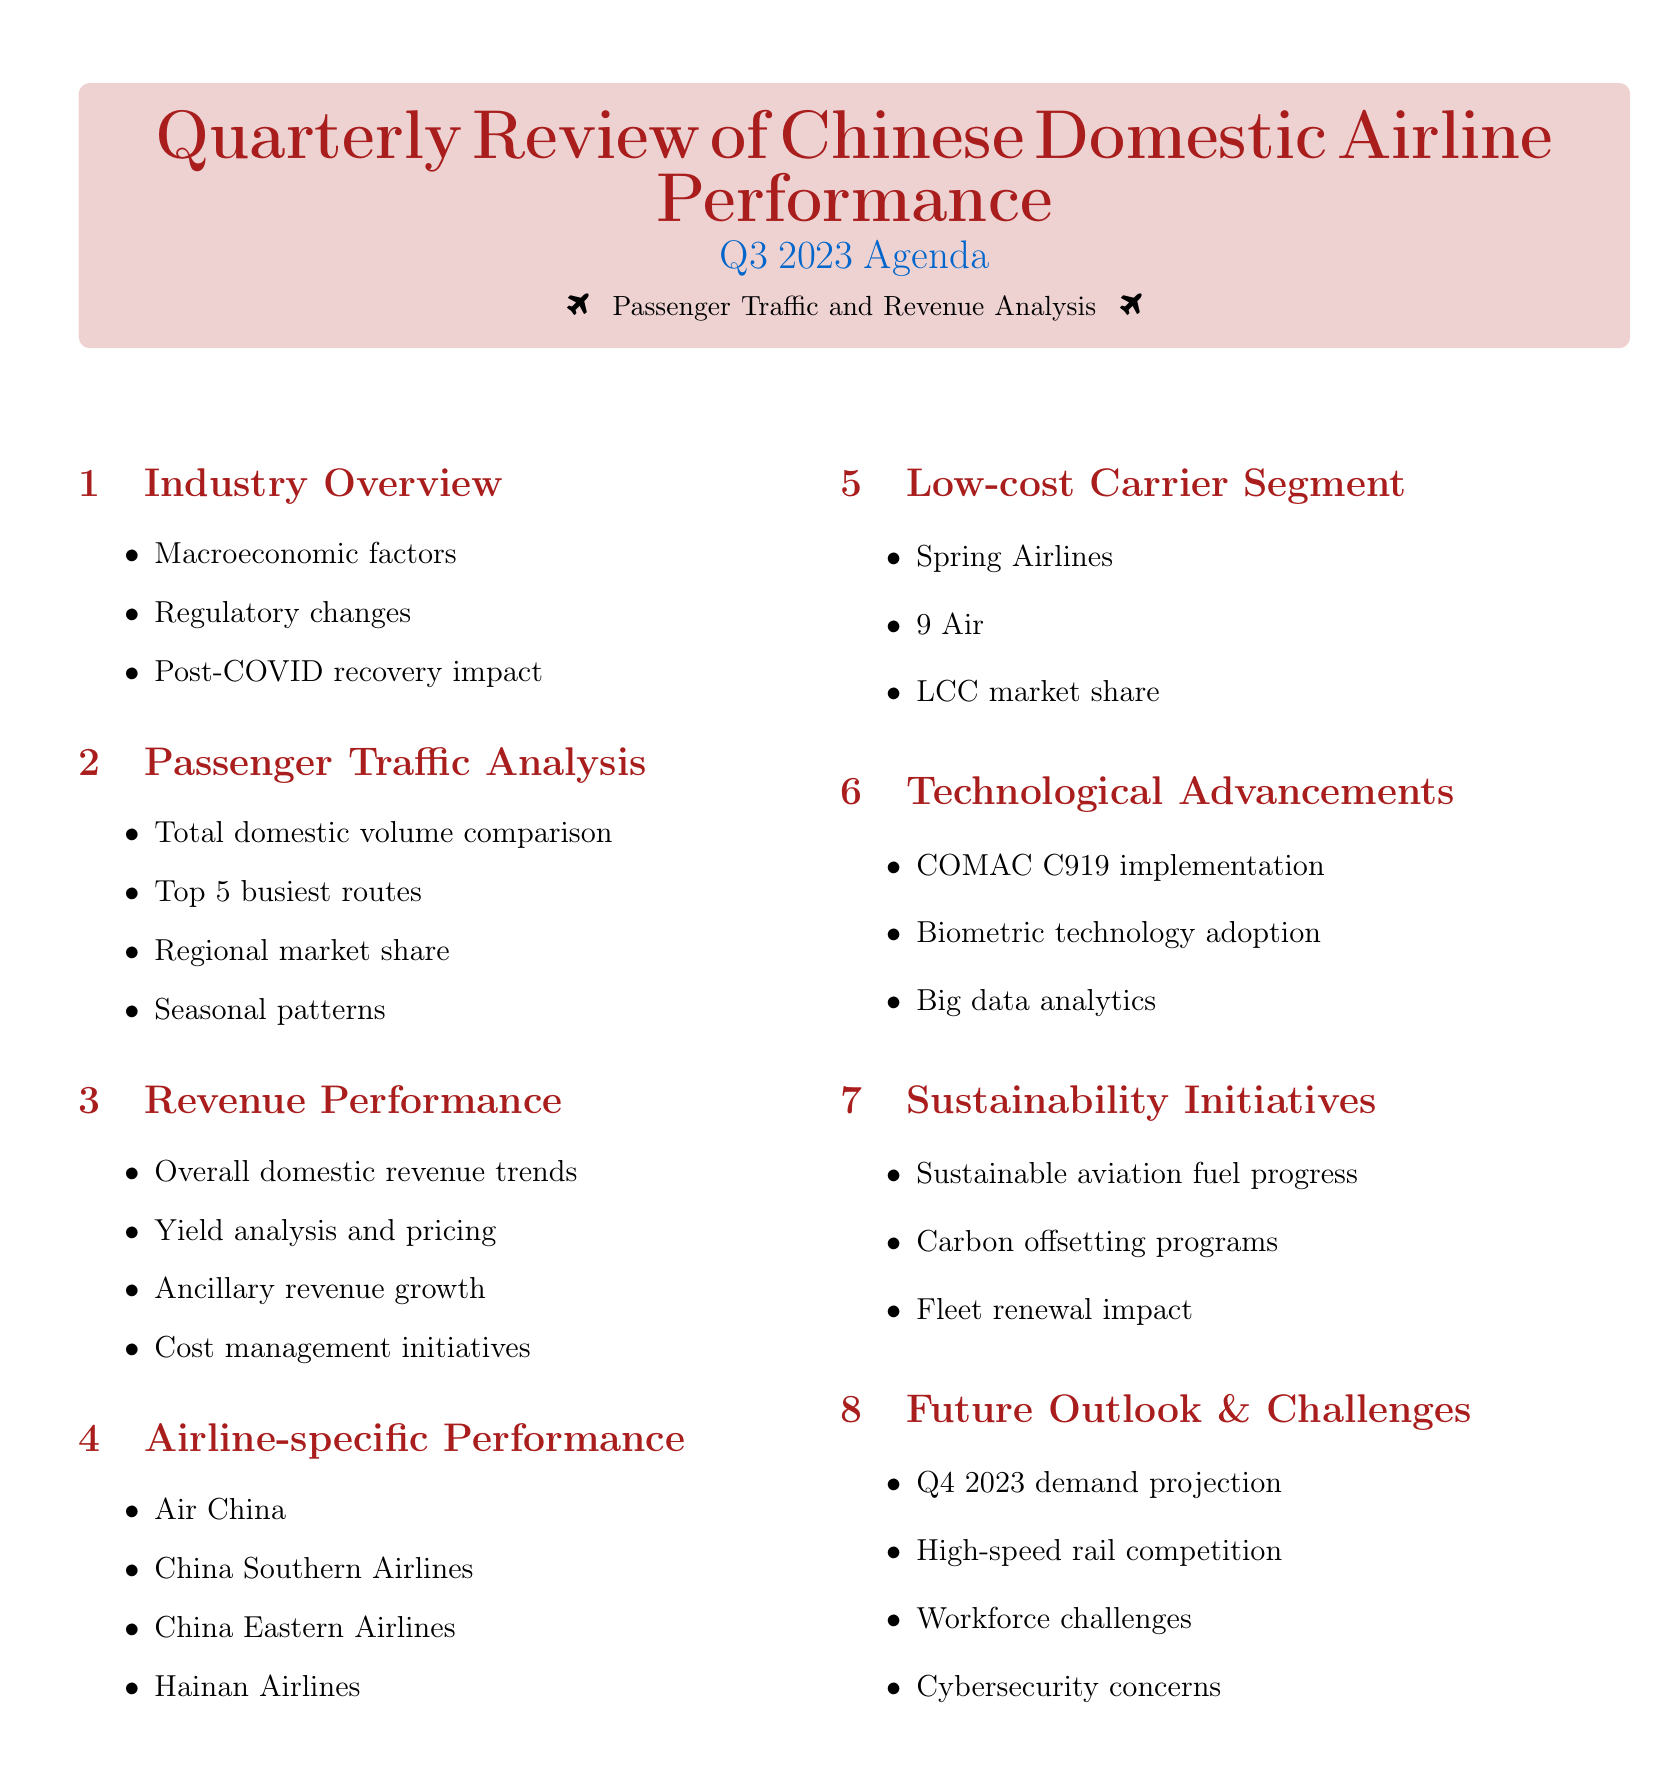what is the main topic of the agenda? The main topic of the agenda is outlined in the document title, which encompasses a review of the Chinese Domestic Airline Performance.
Answer: Quarterly Review of Chinese Domestic Airline Performance which quarter's performance is being reviewed? The document clearly states the specific quarter within the title that is under review for performance analysis.
Answer: Q3 2023 how many subtopics are listed under Revenue Performance? The document enumerates the subtopics beneath Revenue Performance, providing insight into the revenue trends and strategies dealt with.
Answer: Four who is mentioned in the Airline-specific Performance section as having undergone restructuring? The document explicitly names the airline focused on post-restructuring performance in the section regarding airline-specific assessments.
Answer: Hainan Airlines what are the potential challenges mentioned for future outlook? The document lists various challenges that may impact the future outlook, highlighting concerns in the aviation industry.
Answer: Workforce challenges, high-speed rail competition, cybersecurity concerns which airline is associated with fleet modernization? The specific airline noted for its fleet modernization efforts is listed under the airline-specific performance section in the document.
Answer: China Eastern Airlines what is included under Technological Advancements? The document provides details on technological improvements that might influence the airline industry.
Answer: COMAC C919 implementation, biometric technology adoption, big data analytics how many busiest domestic routes are analyzed? The analysis in the passenger traffic section of the document indicates the number of top domestic routes considered for performance review.
Answer: Five 